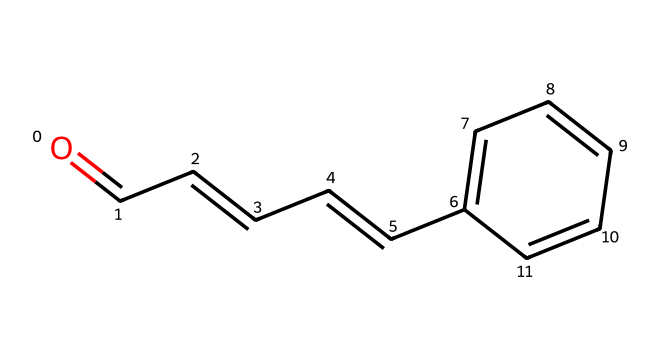What is the functional group present in this compound? The structure includes a carbonyl group (C=O) attached to an alkene (C=C), which characterizes it as an aldehyde.
Answer: aldehyde How many carbon atoms are in cinnamaldehyde? Counting the carbon atoms in the SMILES representation indicates there are 9 carbon atoms present.
Answer: 9 What type of reaction would cinnamaldehyde likely undergo due to its functional group? Aldehydes are known to undergo oxidation reactions, potentially converting to carboxylic acids upon reaction with oxidizing agents.
Answer: oxidation What is the molecular formula of this compound? From the SMILES, we can determine the molecular formula is C9H8O, as it consists of 9 carbon, 8 hydrogen, and 1 oxygen atom.
Answer: C9H8O Which part of this compound contributes to its aromatic properties? The presence of the benzene ring (with alternating double bonds) in the structure gives cinnamaldehyde its aromatic properties.
Answer: benzene ring What physical state is cinnamaldehyde likely to be at room temperature? Given its structure and organic nature, cinnamaldehyde is usually a liquid at room temperature due to its low boiling point relative to solids.
Answer: liquid 